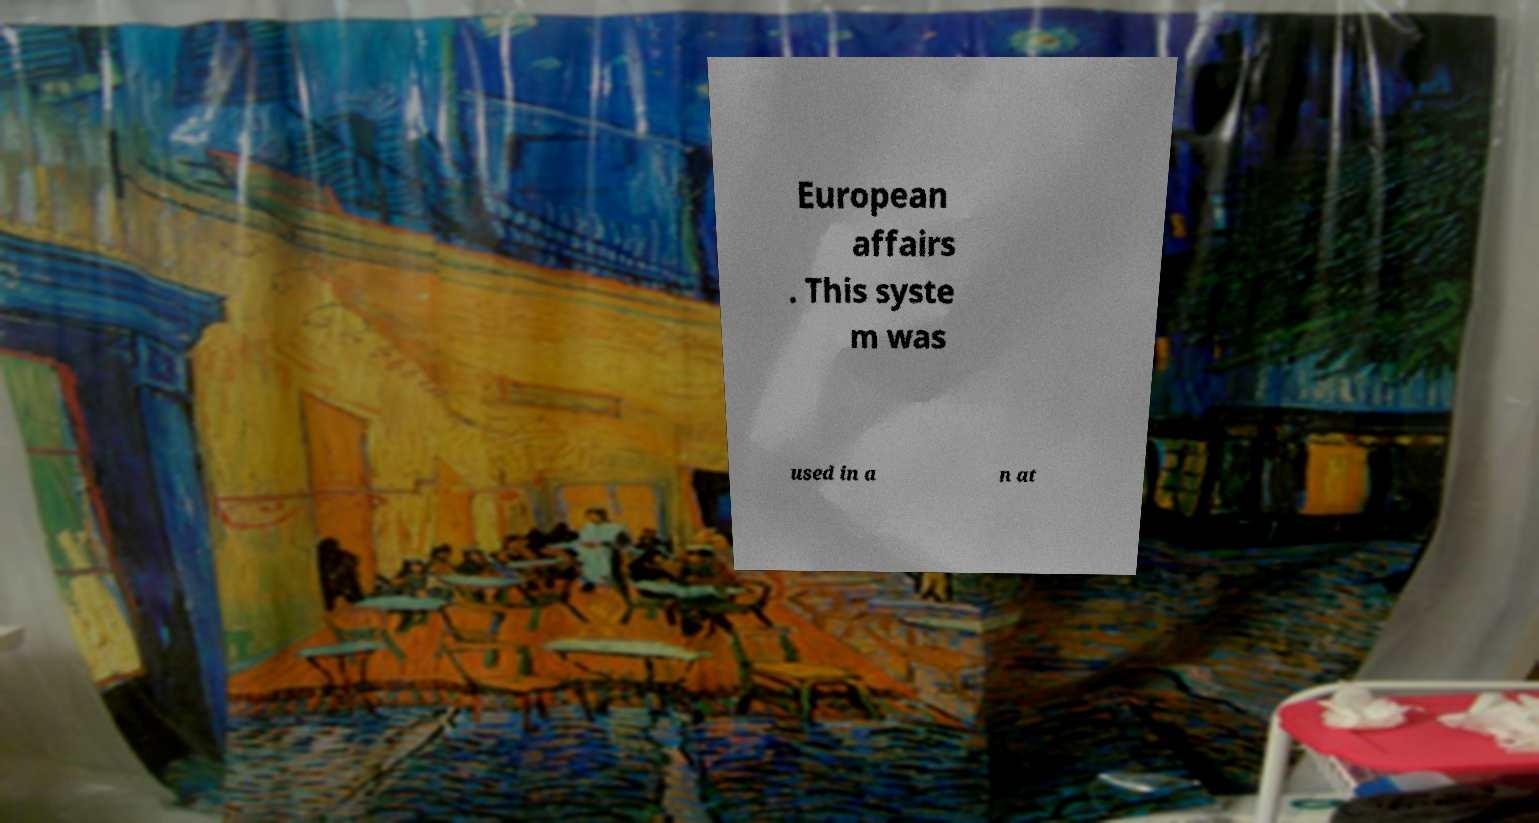I need the written content from this picture converted into text. Can you do that? European affairs . This syste m was used in a n at 